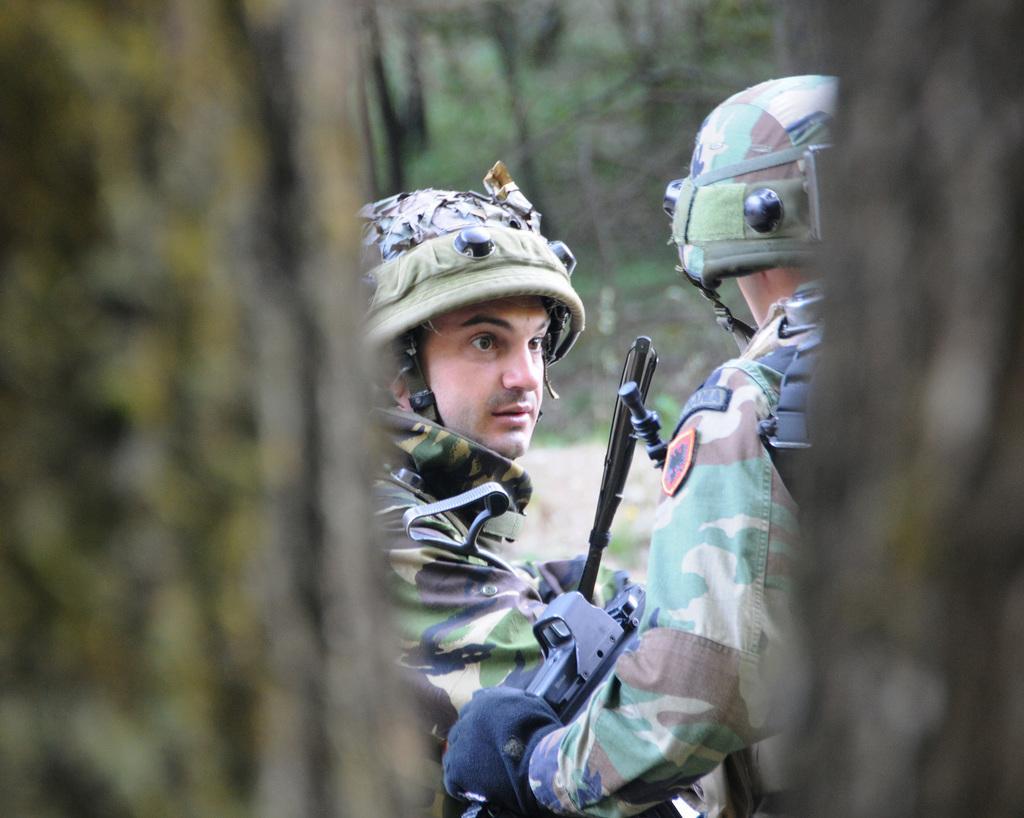Please provide a concise description of this image. In this image we can see the two persons wearing the military uniforms. We can also see the weapons and also the trees. Some part of the image is blurred. 